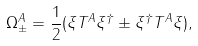Convert formula to latex. <formula><loc_0><loc_0><loc_500><loc_500>\Omega ^ { A } _ { \pm } = \frac { 1 } { 2 } ( \xi T ^ { A } \xi ^ { \dag } \pm \xi ^ { \dag } T ^ { A } \xi ) , \,</formula> 